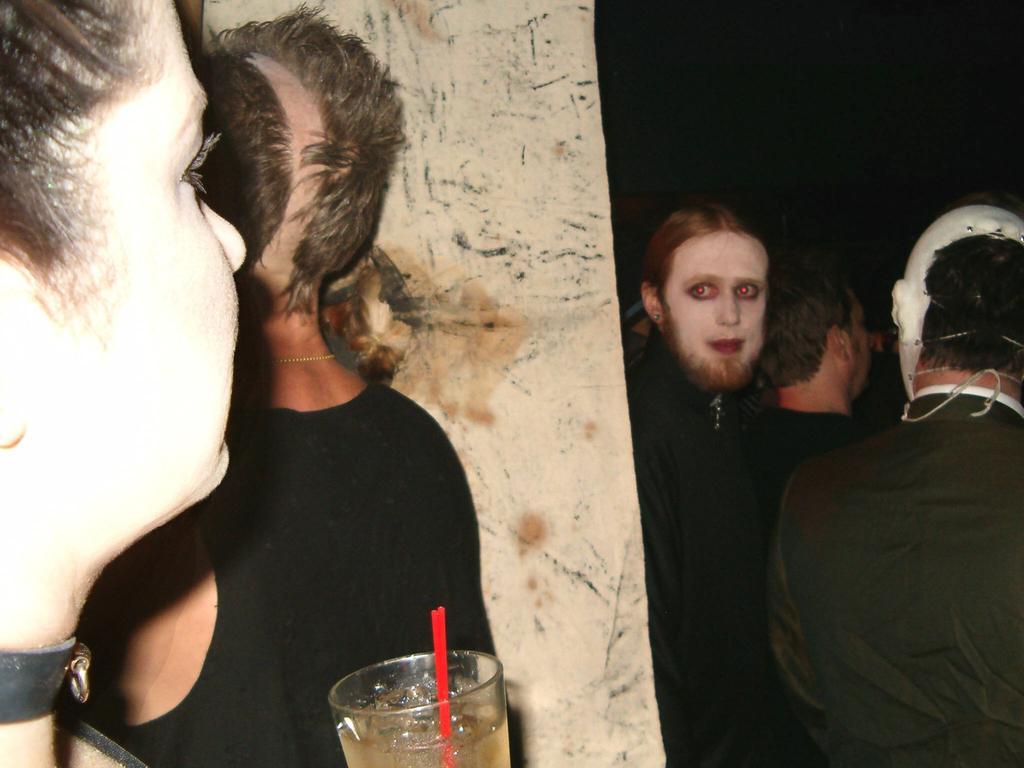How would you summarize this image in a sentence or two? This is the picture of a place where we have a person holding the glass in which there is a straw and in front of the person there are some other people. 